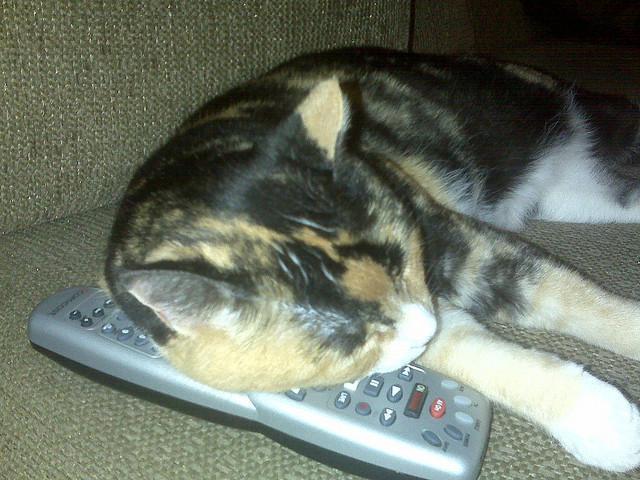How many couches are there?
Give a very brief answer. 1. How many cars are in between the buses?
Give a very brief answer. 0. 